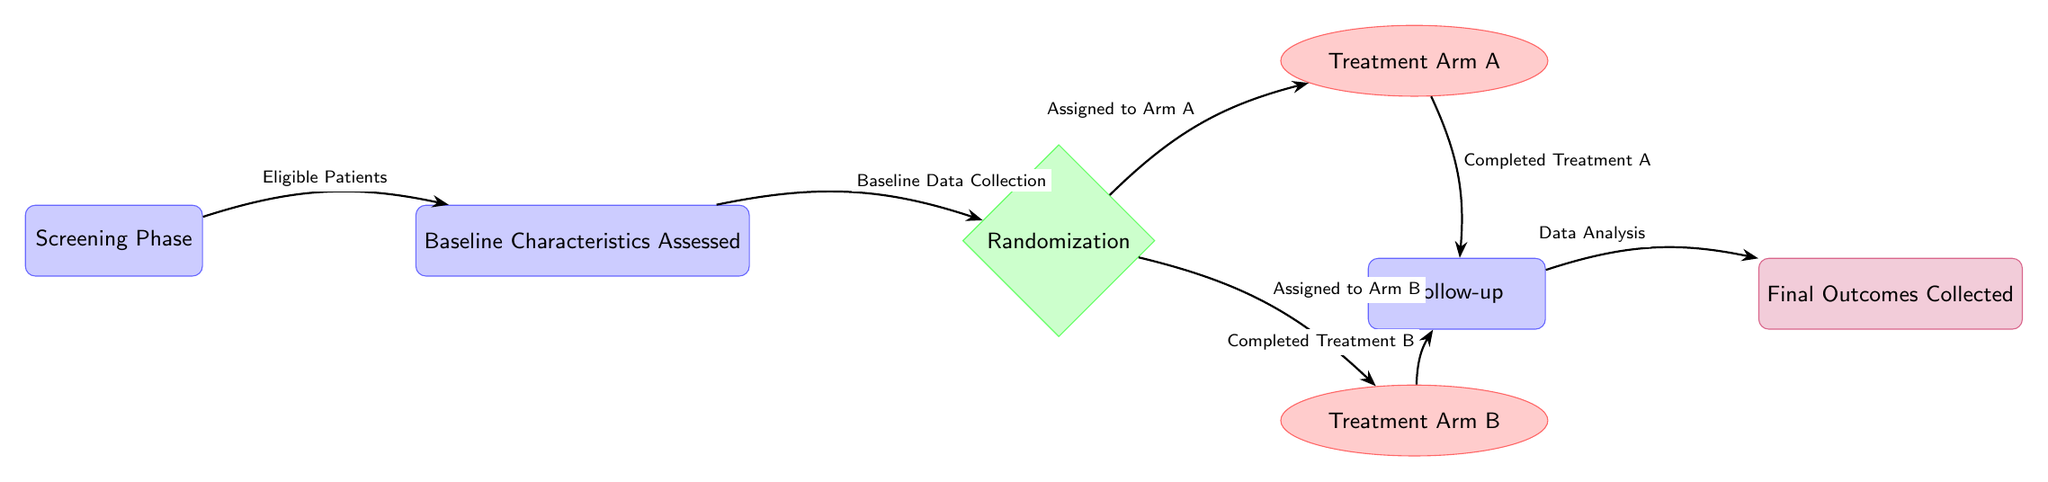What is the first phase in the diagram? The diagram shows that the first phase is labeled "Screening Phase." This is the initial node that patients go through before further assessments.
Answer: Screening Phase How many treatment arms are depicted in the diagram? The diagram features two treatment arms, which are "Treatment Arm A" and "Treatment Arm B." Each arm is represented by an ellipse stemming from the randomization node.
Answer: 2 What is the outcome following the Follow-up phase? The outcome after the Follow-up phase is indicated as "Final Outcomes Collected." This shows the results gathered after patients complete their respective treatments.
Answer: Final Outcomes Collected What connects the Baseline Characteristics Assessed to Randomization? The connection is labeled "Baseline Data Collection," indicating that after assessing baseline characteristics, the next step is randomization of patients to treatment arms.
Answer: Baseline Data Collection What treatment arm do patients enter after "Assigned to Arm B"? Patients who are "Assigned to Arm B" progress to "Completed Treatment B," showing that they go through treatment before follow-up activities.
Answer: Completed Treatment B In the context of the diagram, what does the "Randomization" node represent? The "Randomization" node represents the decision-making process where eligible patients are randomly assigned to one of the two treatment arms. This process is crucial for the trial's integrity.
Answer: Randomization After completing treatment in Arm A, what phase do patients enter next? After "Completed Treatment A," patients enter the "Follow-up" phase. This shows the progression from treatment completion to the subsequent activities of data analysis.
Answer: Follow-up What is the purpose of the Follow-up phase in the clinical trial? The Follow-up phase serves to collect data on treatment effects and other relevant outcomes, hence laying the groundwork for data analysis after the treatments.
Answer: Follow-up How does the diagram illustrate the transition of patients through different phases? The diagram illustrates transitions using directed arrows labeled with text, which show the flow from one phase to another and the actions taken at each step.
Answer: Directed arrows and text labels 